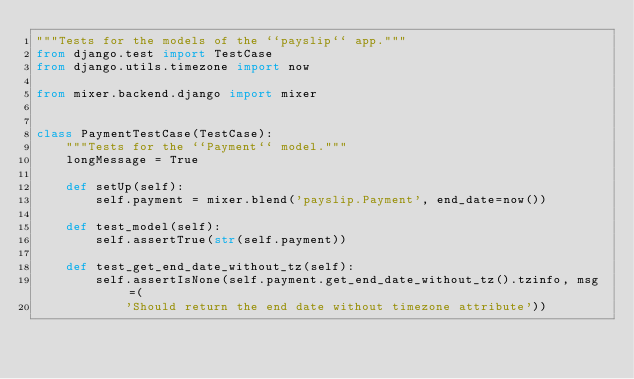Convert code to text. <code><loc_0><loc_0><loc_500><loc_500><_Python_>"""Tests for the models of the ``payslip`` app."""
from django.test import TestCase
from django.utils.timezone import now

from mixer.backend.django import mixer


class PaymentTestCase(TestCase):
    """Tests for the ``Payment`` model."""
    longMessage = True

    def setUp(self):
        self.payment = mixer.blend('payslip.Payment', end_date=now())

    def test_model(self):
        self.assertTrue(str(self.payment))

    def test_get_end_date_without_tz(self):
        self.assertIsNone(self.payment.get_end_date_without_tz().tzinfo, msg=(
            'Should return the end date without timezone attribute'))
</code> 